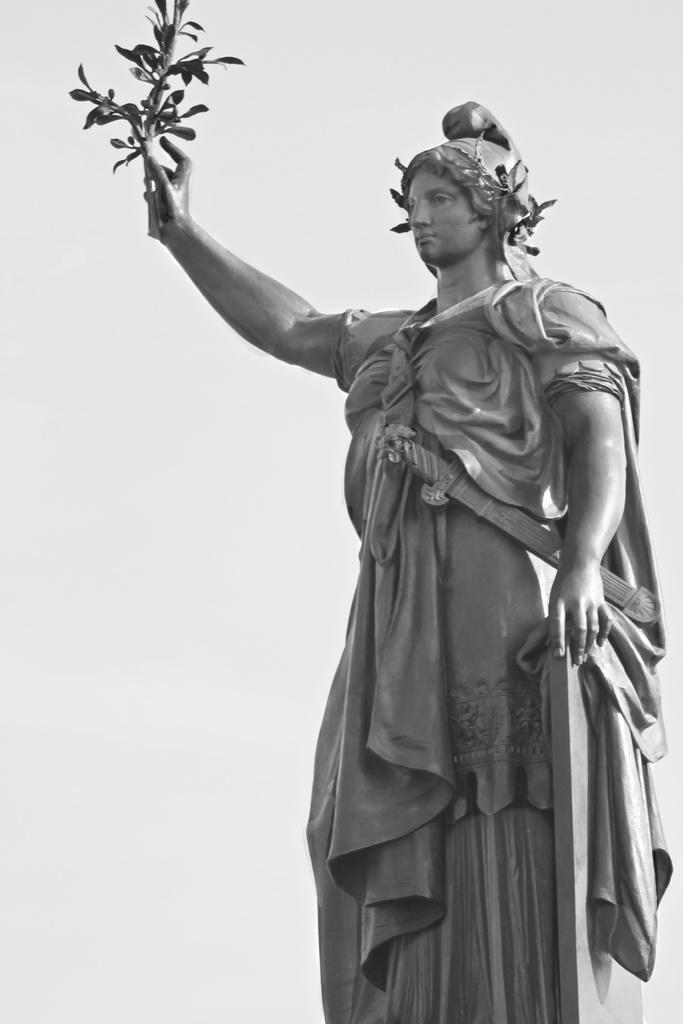What is the main subject of the image? There is a statue of a person in the image. What is the statue holding in their hand? The statue is holding a plant with their hand. What color is the background of the image? The background of the image is white. Can you tell me how many pets are visible in the image? There are no pets present in the image; it features a statue holding a plant. What type of battle is taking place in the image? There is no battle present in the image; it features a statue holding a plant against a white background. 